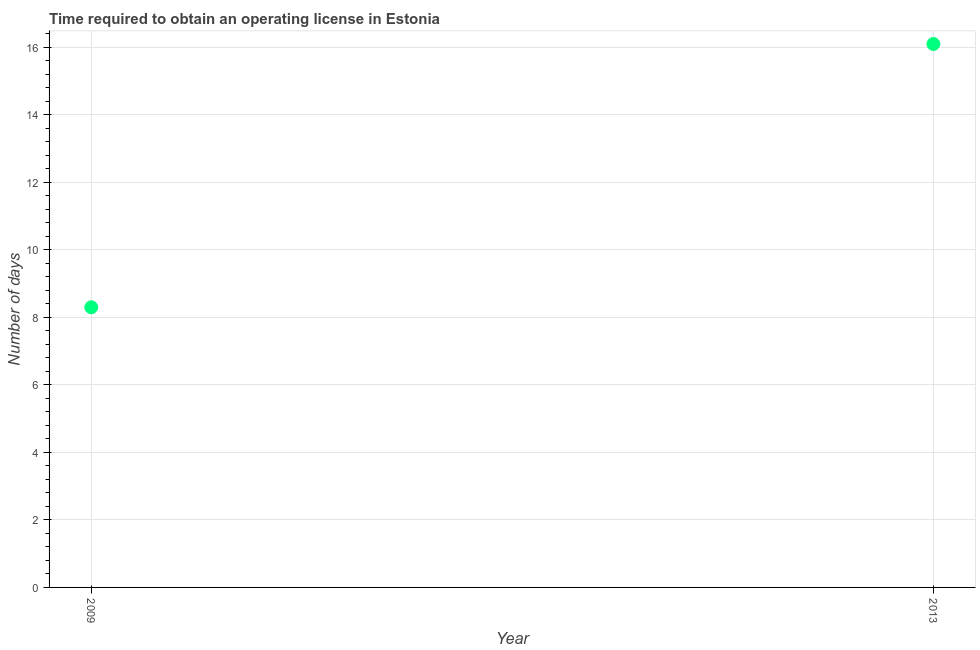Across all years, what is the maximum number of days to obtain operating license?
Ensure brevity in your answer.  16.1. In which year was the number of days to obtain operating license maximum?
Offer a very short reply. 2013. In which year was the number of days to obtain operating license minimum?
Provide a succinct answer. 2009. What is the sum of the number of days to obtain operating license?
Provide a succinct answer. 24.4. What is the difference between the number of days to obtain operating license in 2009 and 2013?
Your answer should be very brief. -7.8. What is the average number of days to obtain operating license per year?
Ensure brevity in your answer.  12.2. What is the median number of days to obtain operating license?
Provide a succinct answer. 12.2. In how many years, is the number of days to obtain operating license greater than 2.8 days?
Offer a terse response. 2. What is the ratio of the number of days to obtain operating license in 2009 to that in 2013?
Keep it short and to the point. 0.52. Is the number of days to obtain operating license in 2009 less than that in 2013?
Your answer should be very brief. Yes. Does the number of days to obtain operating license monotonically increase over the years?
Your response must be concise. Yes. How many dotlines are there?
Your answer should be very brief. 1. What is the difference between two consecutive major ticks on the Y-axis?
Your answer should be very brief. 2. Does the graph contain any zero values?
Offer a terse response. No. What is the title of the graph?
Keep it short and to the point. Time required to obtain an operating license in Estonia. What is the label or title of the X-axis?
Provide a succinct answer. Year. What is the label or title of the Y-axis?
Your answer should be very brief. Number of days. What is the Number of days in 2009?
Give a very brief answer. 8.3. What is the ratio of the Number of days in 2009 to that in 2013?
Offer a terse response. 0.52. 